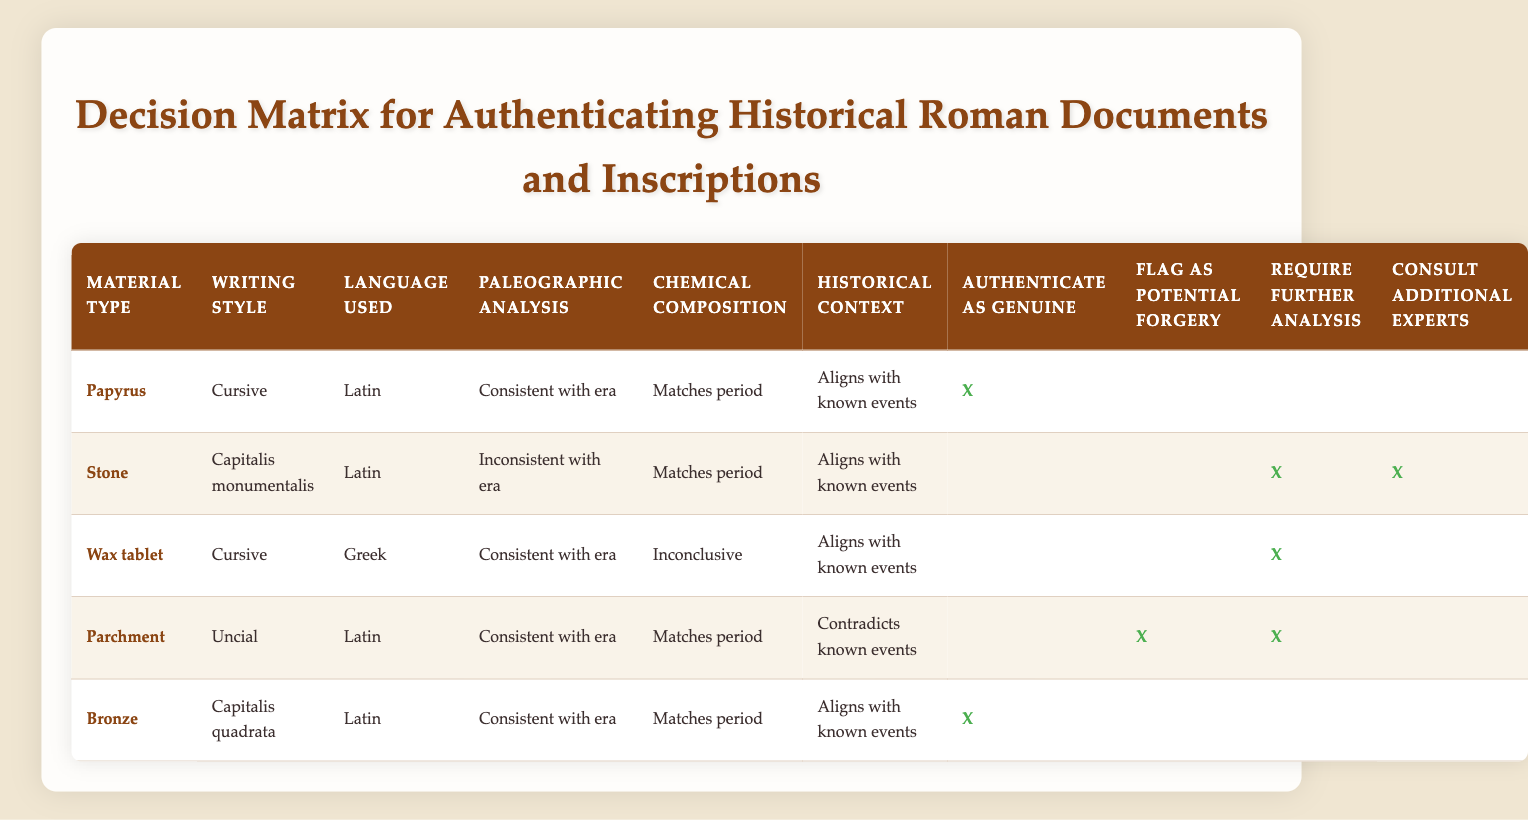What is the authenticity status of papyrus documents? The table indicates that documents made of papyrus, written in cursive Latin, with a paleographic analysis consistent with the era, and matching chemical composition, are authenticated as genuine. Therefore, the action taken is to authenticate as genuine.
Answer: Authenticate as genuine How many materials require further analysis? Reviewing the table, we see that a total of three materials—Stone, Wax tablet, and Parchment—indicate the need for further analysis. Thus, their actions reflect the requirement for further analysis.
Answer: Three Is the writing style of Capitalis monumentalis consistent with the era for stone inscriptions? The table shows that the paleographic analysis for stone inscriptions written in Capitalis monumentalis is inconsistent with the era. Hence, the fact is true.
Answer: No Which materials are authenticated as genuine? The authentic documents according to the table are papyrus and bronze. Both have consistent elements such as material type, writing style, paleographic analysis, chemical composition, and historical context in alignment with known events.
Answer: Papyrus and Bronze If a document made of parchment has a historical context that contradicts known events, what actions are recommended? The table shows that for parchment documents with a historical context that contradicts known events, the recommended actions are to flag as potential forgery and require further analysis. This involves both actions being indicated in the respective columns.
Answer: Flag as potential forgery and require further analysis Are there any documents written in Greek that are authenticated as genuine? The table lists one document type that is written in Greek, which is the wax tablet. However, it does not authenticate this document as genuine; instead, it requires further analysis. Thus, the answer is based on the action taken.
Answer: No How many expert consultations are required for the stone and wax tablet documents? For stone materials, the need for expert consultation is indicated, while the wax tablet does not require this consultation. Therefore, there is only one document (the stone) that requires expert consultation based on the table.
Answer: One Which document type has a paleographic analysis consistent with the era, yet requires further analysis? The document type that fits the conditions of being consistent in paleographic analysis, but still requiring further analysis is the wax tablet, which has inconclusive chemical composition analysis.
Answer: Wax tablet What can be concluded about documents made of bronze? The table indicates that bronze documents written in Capitalis quadrata, which have a consistent paleographic analysis, matching chemical composition, and a historical context that aligns with known events, are authenticated as genuine.
Answer: Authenticate as genuine 